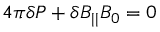<formula> <loc_0><loc_0><loc_500><loc_500>4 \pi \delta P + \delta B _ { | | } B _ { 0 } = 0</formula> 